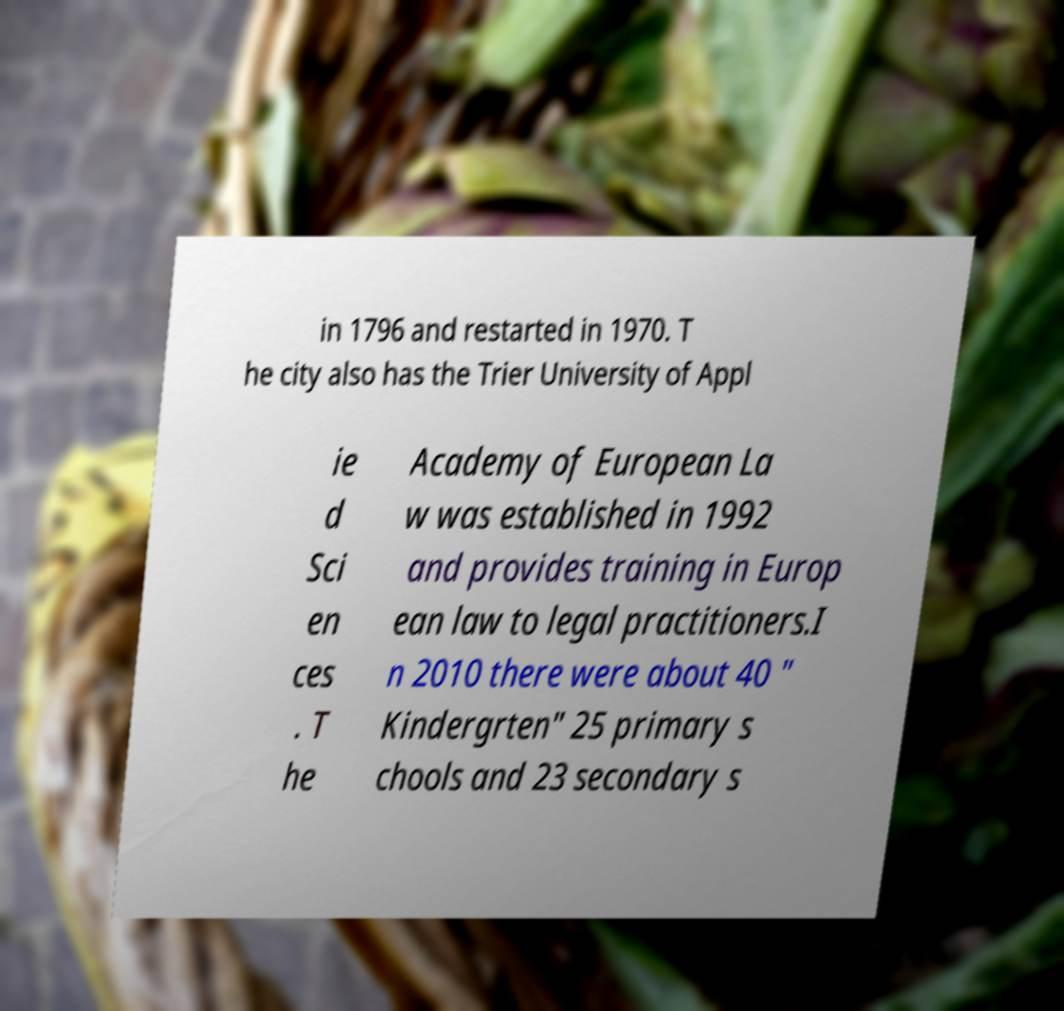Please identify and transcribe the text found in this image. in 1796 and restarted in 1970. T he city also has the Trier University of Appl ie d Sci en ces . T he Academy of European La w was established in 1992 and provides training in Europ ean law to legal practitioners.I n 2010 there were about 40 " Kindergrten" 25 primary s chools and 23 secondary s 